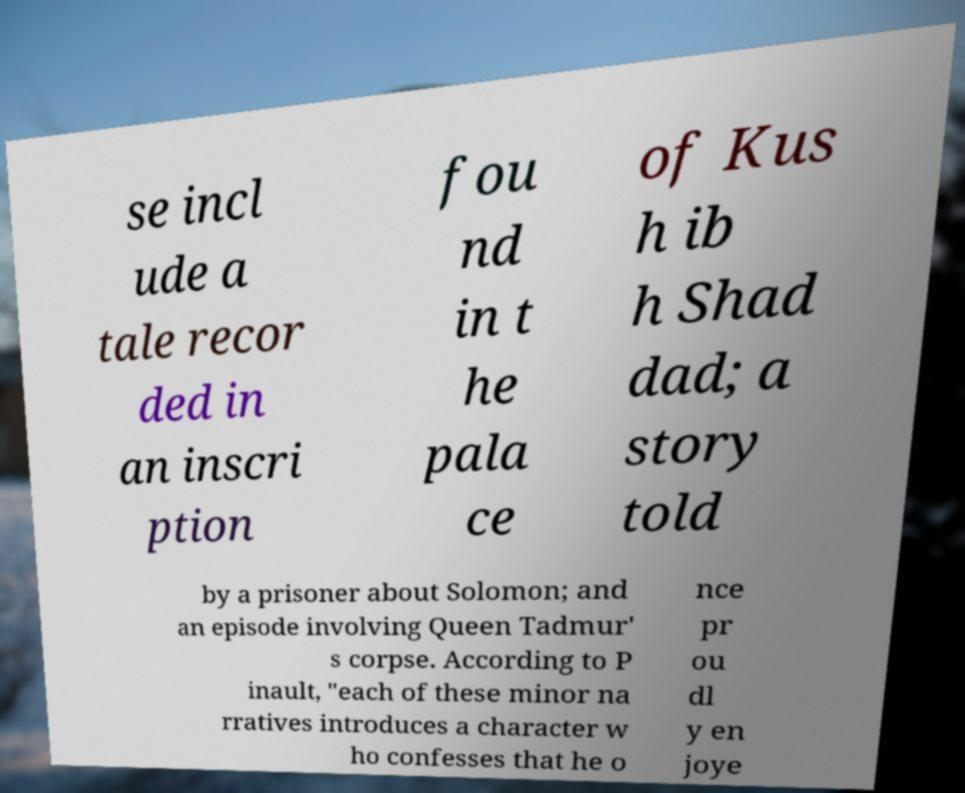What messages or text are displayed in this image? I need them in a readable, typed format. se incl ude a tale recor ded in an inscri ption fou nd in t he pala ce of Kus h ib h Shad dad; a story told by a prisoner about Solomon; and an episode involving Queen Tadmur' s corpse. According to P inault, "each of these minor na rratives introduces a character w ho confesses that he o nce pr ou dl y en joye 